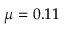Convert formula to latex. <formula><loc_0><loc_0><loc_500><loc_500>\mu = 0 . 1 1</formula> 